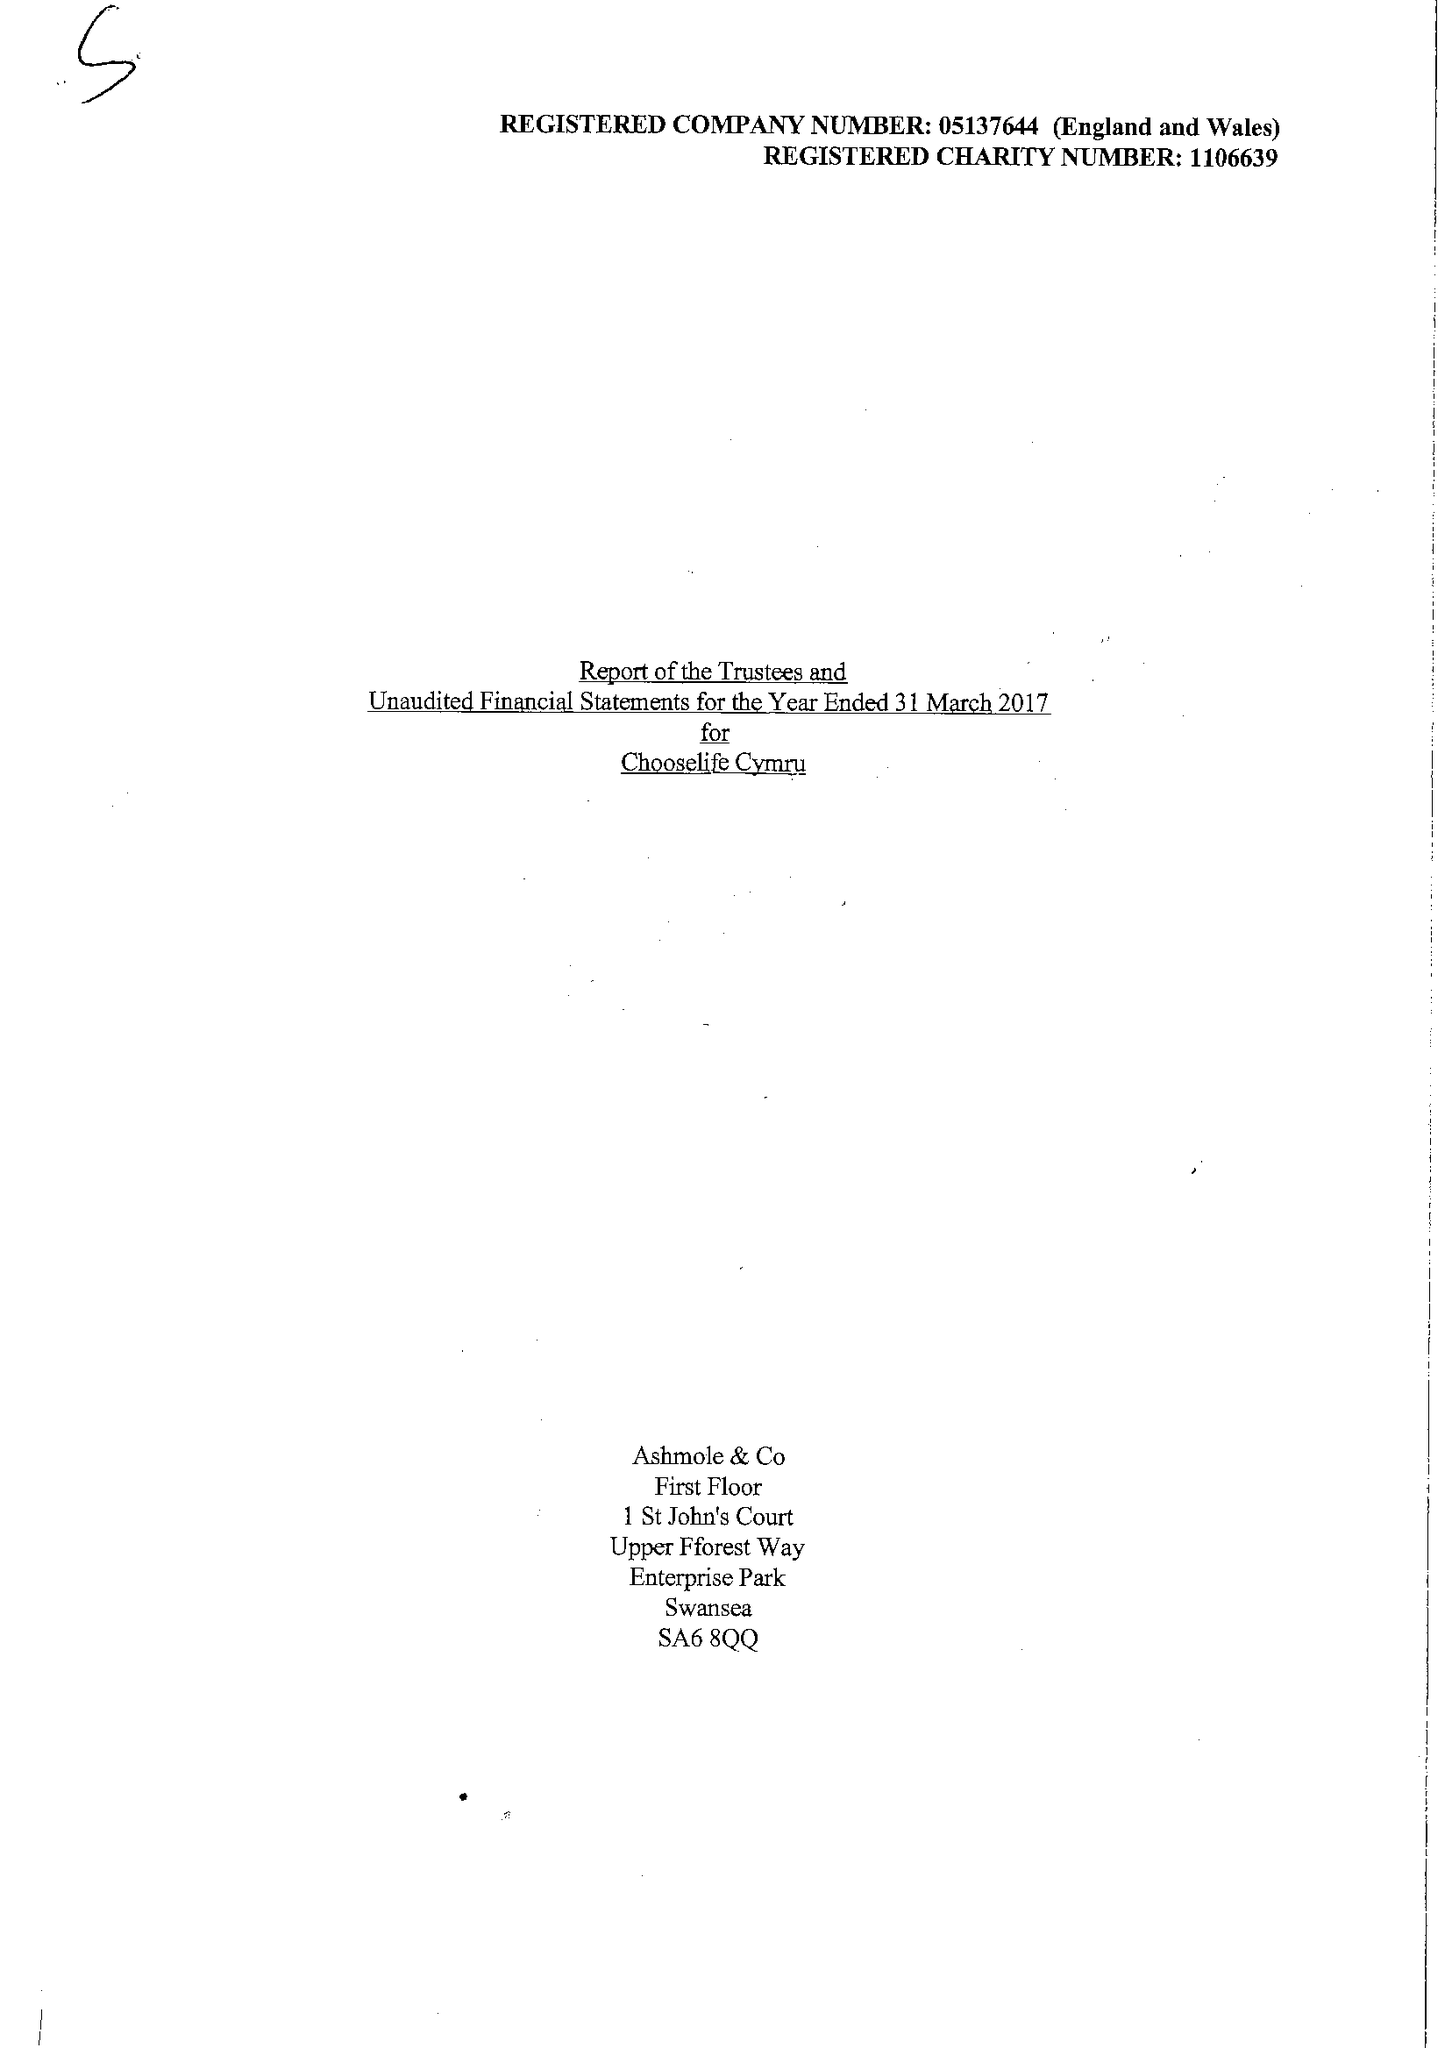What is the value for the report_date?
Answer the question using a single word or phrase. 2017-03-31 